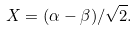<formula> <loc_0><loc_0><loc_500><loc_500>X = ( \alpha - \beta ) / \sqrt { 2 } .</formula> 